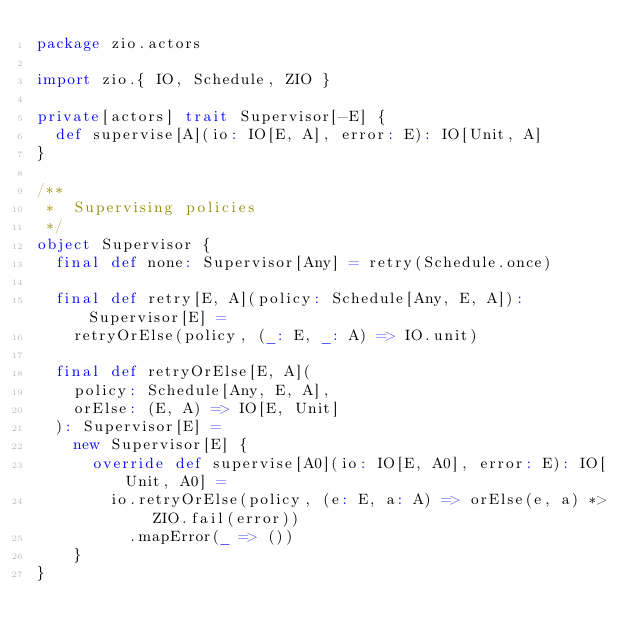<code> <loc_0><loc_0><loc_500><loc_500><_Scala_>package zio.actors

import zio.{ IO, Schedule, ZIO }

private[actors] trait Supervisor[-E] {
  def supervise[A](io: IO[E, A], error: E): IO[Unit, A]
}

/**
 *  Supervising policies
 */
object Supervisor {
  final def none: Supervisor[Any] = retry(Schedule.once)

  final def retry[E, A](policy: Schedule[Any, E, A]): Supervisor[E] =
    retryOrElse(policy, (_: E, _: A) => IO.unit)

  final def retryOrElse[E, A](
    policy: Schedule[Any, E, A],
    orElse: (E, A) => IO[E, Unit]
  ): Supervisor[E] =
    new Supervisor[E] {
      override def supervise[A0](io: IO[E, A0], error: E): IO[Unit, A0] =
        io.retryOrElse(policy, (e: E, a: A) => orElse(e, a) *> ZIO.fail(error))
          .mapError(_ => ())
    }
}
</code> 